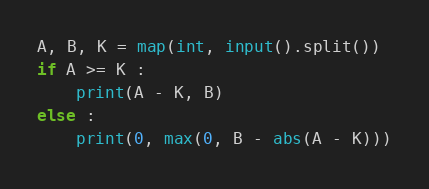Convert code to text. <code><loc_0><loc_0><loc_500><loc_500><_Python_>A, B, K = map(int, input().split())
if A >= K :
    print(A - K, B)
else :
    print(0, max(0, B - abs(A - K)))
</code> 